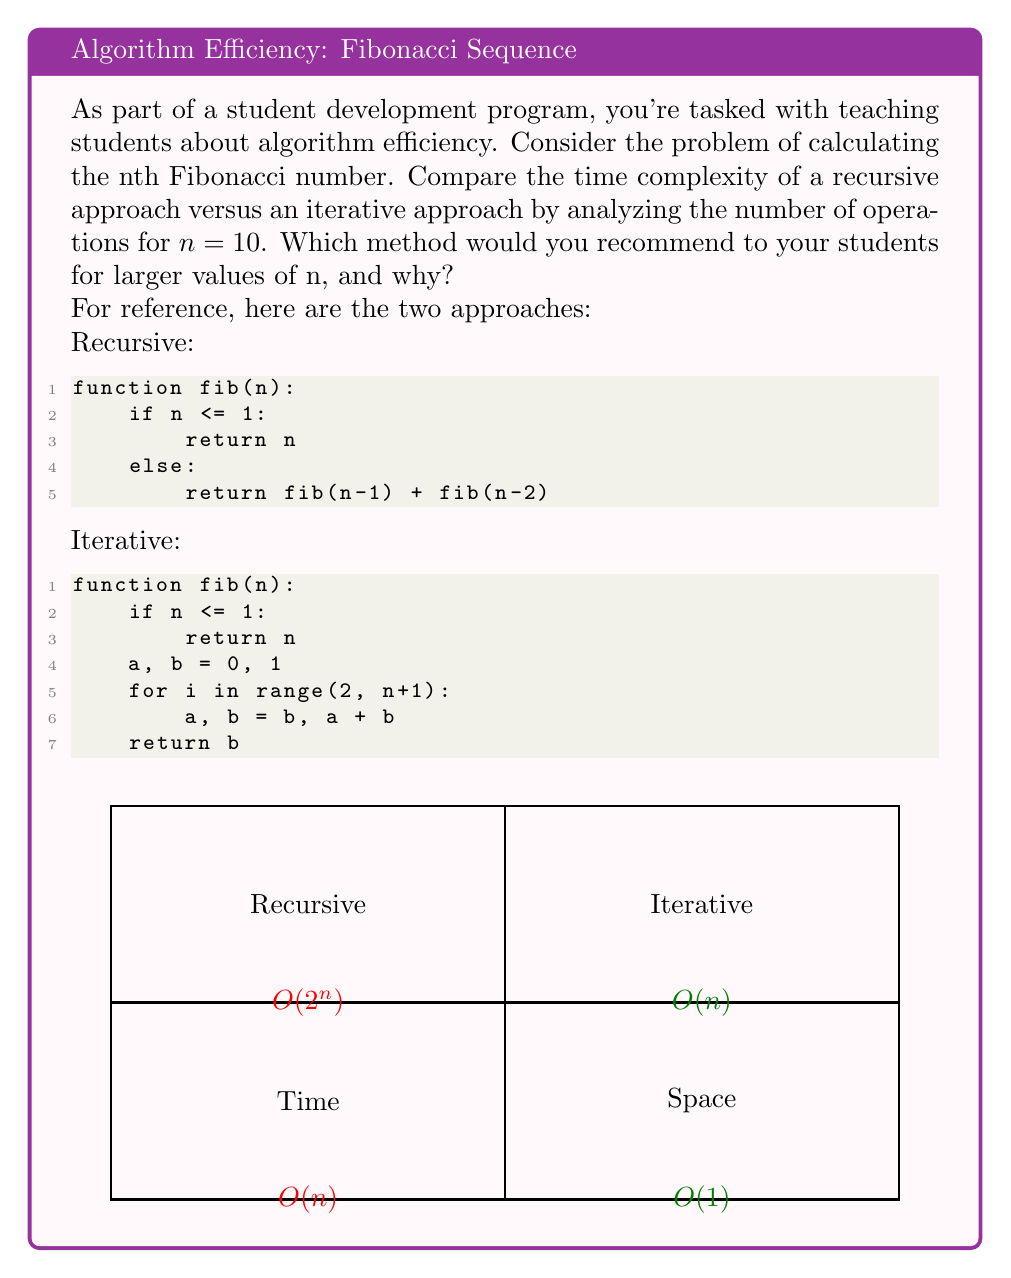Show me your answer to this math problem. Let's analyze both approaches step by step:

1. Recursive Approach:
   - Time Complexity: $O(2^n)$
   - For $n = 10$, the number of function calls is approximately $2^{10} = 1024$
   - This is because each call to fib(n) results in two more calls: fib(n-1) and fib(n-2)
   - The recursion tree has a depth of n and each level doubles the number of calls
   - Space Complexity: $O(n)$ due to the call stack

2. Iterative Approach:
   - Time Complexity: $O(n)$
   - For $n = 10$, the loop runs exactly 9 times (from 2 to 10)
   - Each iteration performs a constant number of operations
   - Space Complexity: $O(1)$ as it uses only a fixed number of variables

3. Comparison for $n = 10$:
   - Recursive: ~1024 operations
   - Iterative: 9 operations

4. Recommendation:
   For larger values of n, the iterative approach is strongly recommended because:
   - It's significantly faster, with linear time complexity vs exponential
   - It uses constant space, preventing stack overflow for large n
   - It's more predictable in terms of execution time
   - It aligns with efficient programming practices students should learn

5. Educational Value:
   - This comparison demonstrates the importance of algorithm choice
   - It shows how seemingly simple choices can have dramatic performance implications
   - It introduces students to the concept of time and space complexity
   - It encourages critical thinking about different problem-solving approaches
Answer: Iterative approach; $O(n)$ time complexity vs $O(2^n)$, more efficient for large n. 